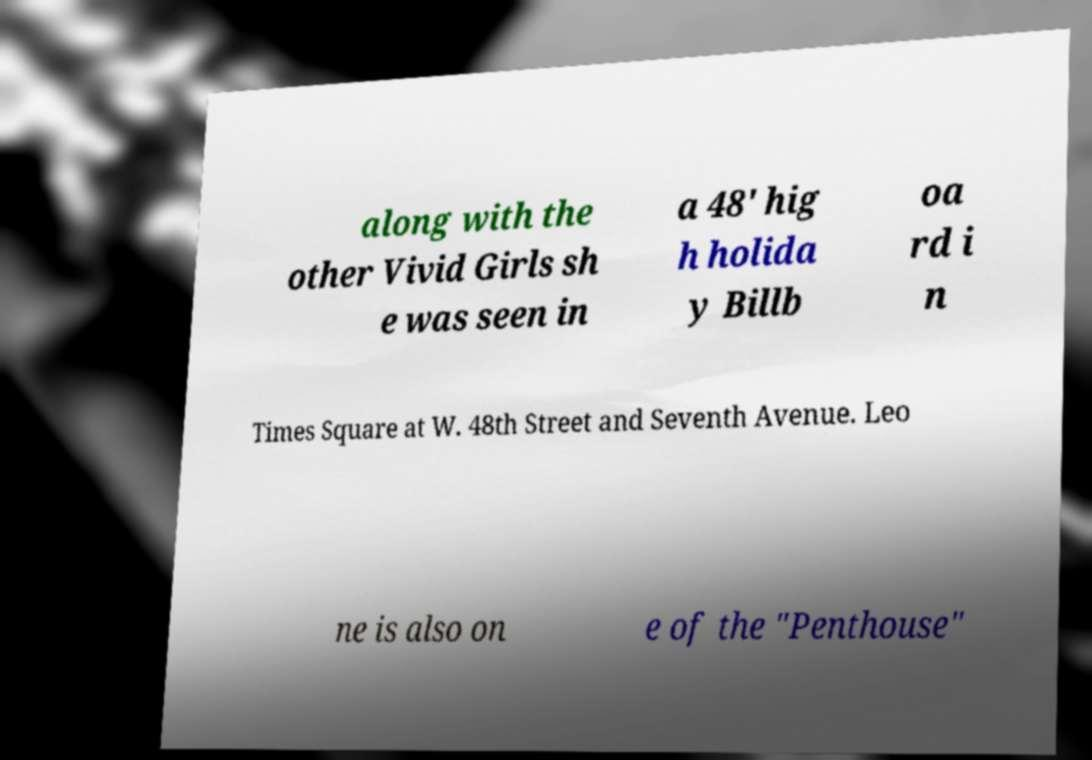Please read and relay the text visible in this image. What does it say? along with the other Vivid Girls sh e was seen in a 48' hig h holida y Billb oa rd i n Times Square at W. 48th Street and Seventh Avenue. Leo ne is also on e of the "Penthouse" 